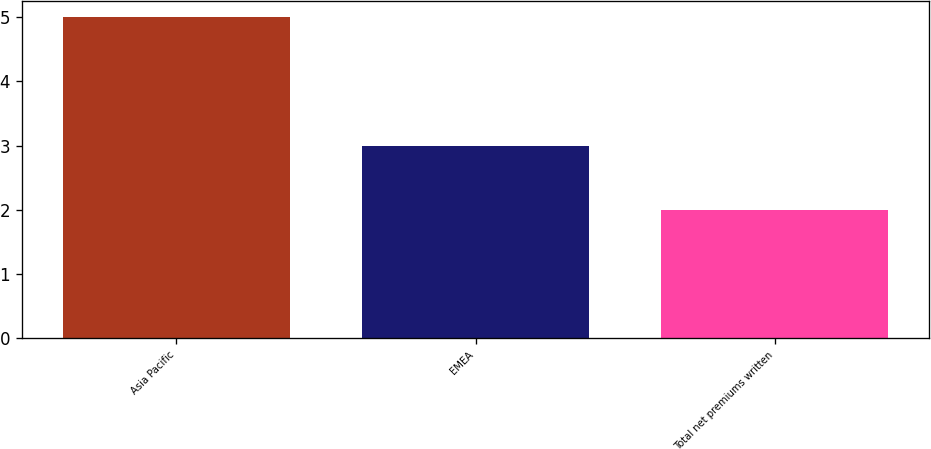Convert chart. <chart><loc_0><loc_0><loc_500><loc_500><bar_chart><fcel>Asia Pacific<fcel>EMEA<fcel>Total net premiums written<nl><fcel>5<fcel>3<fcel>2<nl></chart> 